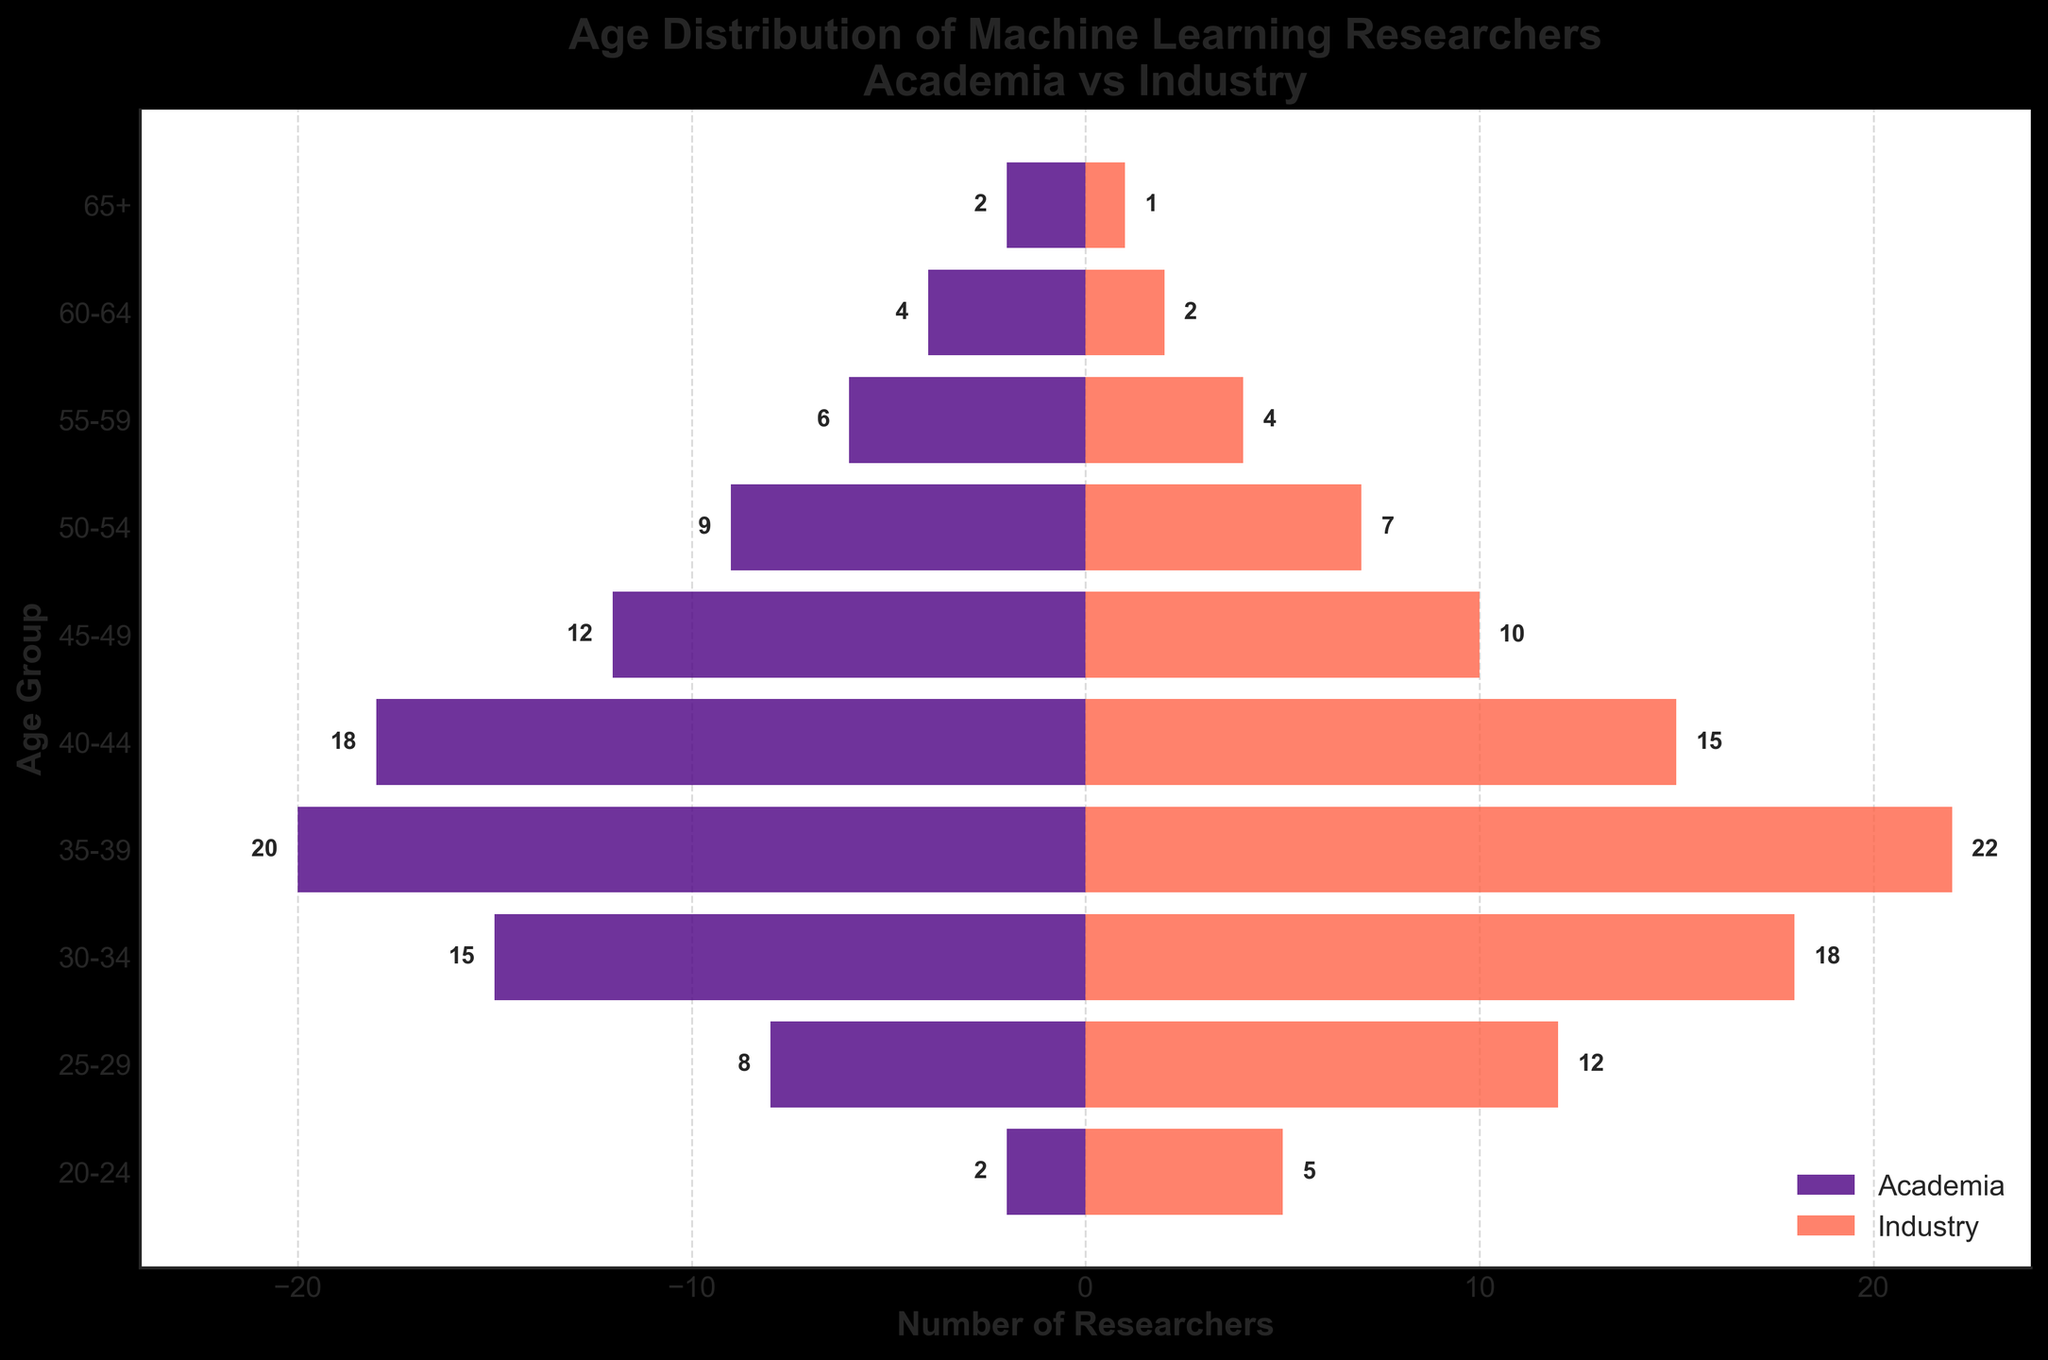What's the title of the plot? The title is located at the top of the plot. It reads 'Age Distribution of Machine Learning Researchers\nAcademia vs Industry.'
Answer: Age Distribution of Machine Learning Researchers\nAcademia vs Industry What are the colors used for Academia and Industry? The legend at the bottom right of the plot indicates the colors. Academia is shown in dark purple, and Industry is shown in red-orange.
Answer: Dark purple (Academia), Red-orange (Industry) Which age group has the highest number of researchers in Academia? Look at the left side of the pyramid where the bars are for Academia. The age group 35-39 has the longest bar, indicating the highest count.
Answer: 35-39 How many 30-34 age group researchers are depicted in Academia and Industry combined? Identify the values for the 30-34 age group in both Academia and Industry. The values are 15 (Academia) and 18 (Industry). Add these values together: 15 + 18 = 33.
Answer: 33 In which age group does Academia have more researchers compared to Industry? By visually comparing the lengths of the bars, the age groups with longer bars on the Academia side are 20-24, 40-44, 45-49, 50-54, 55-59, 60-64, and 65+.
Answer: 20-24, 40-44, 45-49, 50-54, 55-59, 60-64, 65+ For the 50-54 age group, which sector has more researchers and by how many? Compare the length of the bars for the 50-54 age group. The value is 9 for Academia and 7 for Industry. To find the difference, subtract the smaller number from the larger one: 9 - 7 = 2.
Answer: Academia by 2 What is the average number of researchers in the age groups 25-29, 30-34, and 35-39 for Industry? Identify the values for Industry in the 25-29, 30-34, and 35-39 age groups, which are 12, 18, and 22 respectively. Calculate the average: (12 + 18 + 22) / 3 = 52 / 3 ≈ 17.33.
Answer: 17.33 What is the total number of researchers in the 65+ age group across both Academia and Industry? Sum the values of 65+ age group for both Academia and Industry: 2 (Academia) + 1 (Industry) = 3.
Answer: 3 Which age group in Industry has the fewest researchers? Look at the right side of the pyramid and find the smallest bar length in Industry. The age group with the smallest bar is the 65+ age group with a value of 1.
Answer: 65+ How many researchers in total are there in the age group 40-44? Add the number of researchers in both Academia and Industry for the 40-44 age group: 18 (Academia) + 15 (Industry) = 33.
Answer: 33 